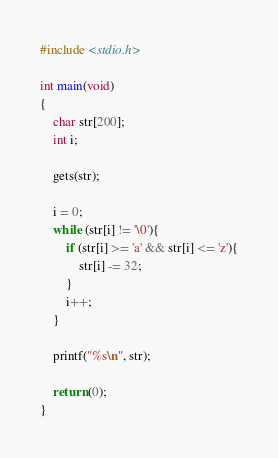Convert code to text. <code><loc_0><loc_0><loc_500><loc_500><_C_>#include <stdio.h>

int main(void)
{
	char str[200];
	int i;
	
	gets(str);
	
	i = 0;
	while (str[i] != '\0'){
		if (str[i] >= 'a' && str[i] <= 'z'){
			str[i] -= 32;
		}
		i++;
	}
	
	printf("%s\n", str);
	
	return (0);
}</code> 